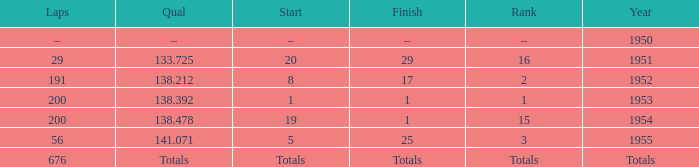What year was the ranking 1? 1953.0. 